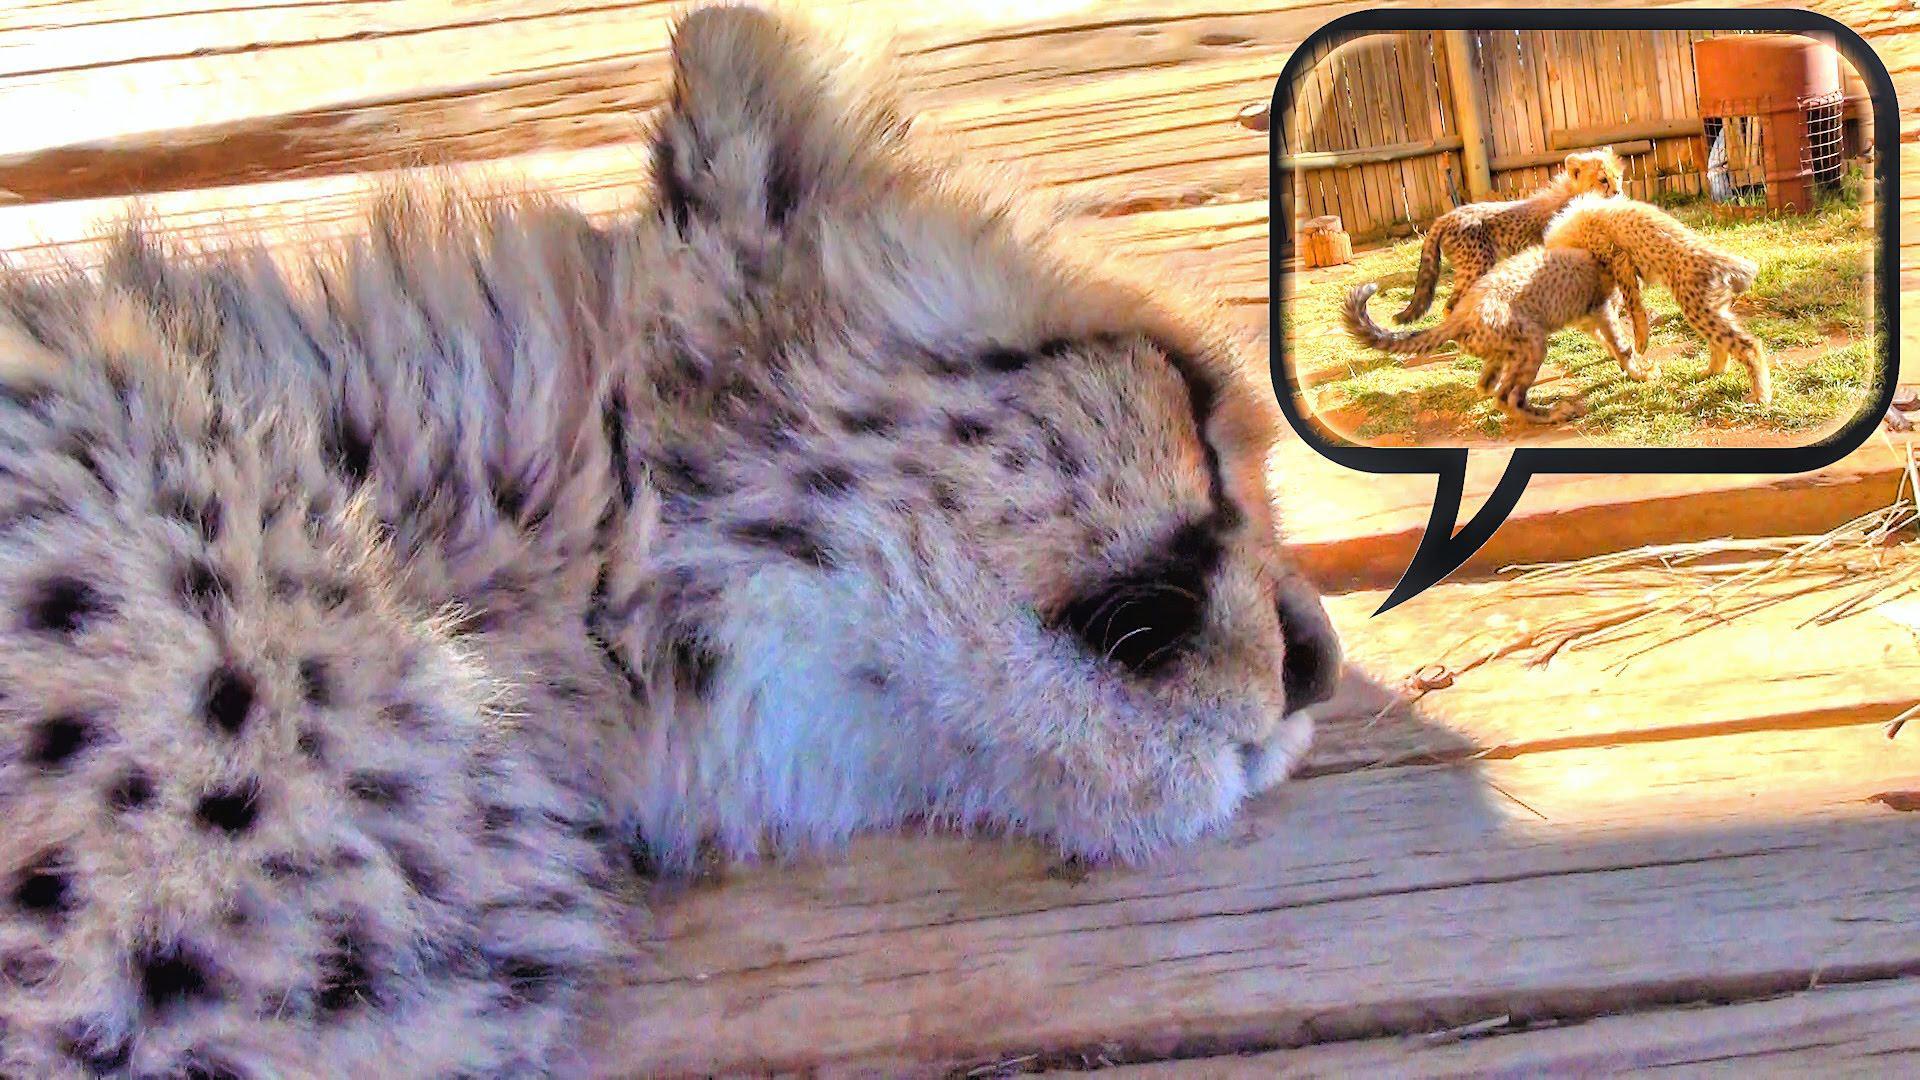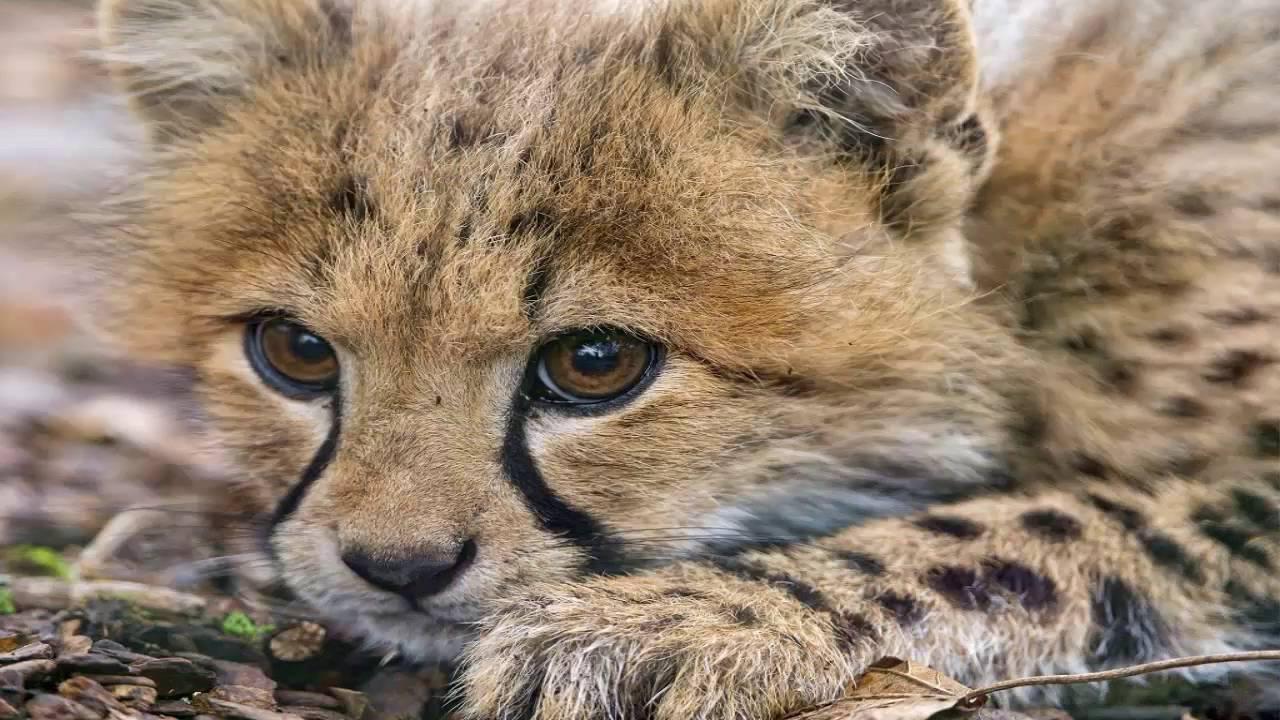The first image is the image on the left, the second image is the image on the right. For the images displayed, is the sentence "A baby leopard is laying next to its mom." factually correct? Answer yes or no. No. The first image is the image on the left, the second image is the image on the right. Considering the images on both sides, is "In the image to the right, a cheetah kitten is laying down, looking forwards." valid? Answer yes or no. Yes. 